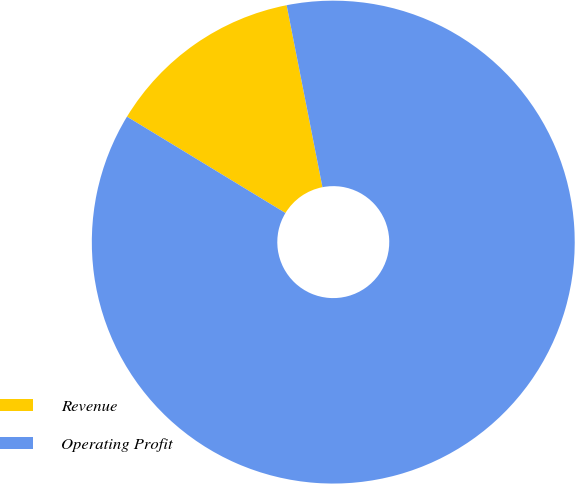Convert chart. <chart><loc_0><loc_0><loc_500><loc_500><pie_chart><fcel>Revenue<fcel>Operating Profit<nl><fcel>13.21%<fcel>86.79%<nl></chart> 